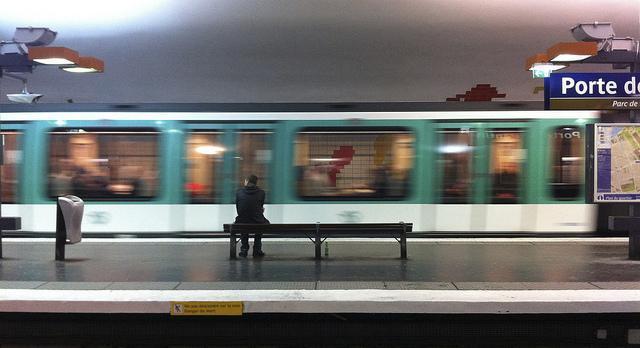What is the most likely location of this station?
Answer the question by selecting the correct answer among the 4 following choices.
Options: Asia, europe, south america, africa. Europe. 